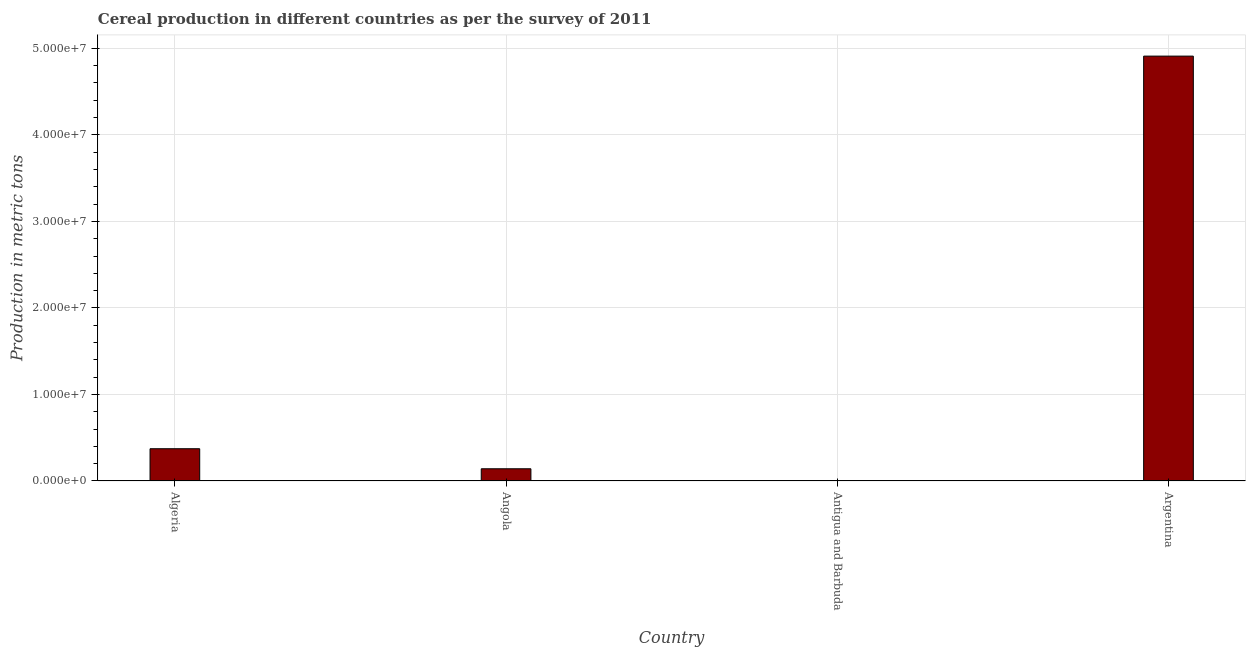Does the graph contain grids?
Offer a very short reply. Yes. What is the title of the graph?
Make the answer very short. Cereal production in different countries as per the survey of 2011. What is the label or title of the X-axis?
Provide a short and direct response. Country. What is the label or title of the Y-axis?
Make the answer very short. Production in metric tons. What is the cereal production in Algeria?
Provide a succinct answer. 3.73e+06. Across all countries, what is the maximum cereal production?
Your answer should be compact. 4.91e+07. Across all countries, what is the minimum cereal production?
Your answer should be compact. 90. In which country was the cereal production minimum?
Make the answer very short. Antigua and Barbuda. What is the sum of the cereal production?
Offer a terse response. 5.42e+07. What is the difference between the cereal production in Algeria and Antigua and Barbuda?
Offer a terse response. 3.73e+06. What is the average cereal production per country?
Make the answer very short. 1.36e+07. What is the median cereal production?
Ensure brevity in your answer.  2.57e+06. In how many countries, is the cereal production greater than 18000000 metric tons?
Your response must be concise. 1. Is the cereal production in Algeria less than that in Argentina?
Give a very brief answer. Yes. Is the difference between the cereal production in Angola and Argentina greater than the difference between any two countries?
Give a very brief answer. No. What is the difference between the highest and the second highest cereal production?
Keep it short and to the point. 4.54e+07. Is the sum of the cereal production in Antigua and Barbuda and Argentina greater than the maximum cereal production across all countries?
Offer a terse response. Yes. What is the difference between the highest and the lowest cereal production?
Your answer should be very brief. 4.91e+07. In how many countries, is the cereal production greater than the average cereal production taken over all countries?
Give a very brief answer. 1. How many bars are there?
Offer a very short reply. 4. How many countries are there in the graph?
Give a very brief answer. 4. Are the values on the major ticks of Y-axis written in scientific E-notation?
Your answer should be compact. Yes. What is the Production in metric tons in Algeria?
Offer a very short reply. 3.73e+06. What is the Production in metric tons of Angola?
Give a very brief answer. 1.41e+06. What is the Production in metric tons in Argentina?
Provide a short and direct response. 4.91e+07. What is the difference between the Production in metric tons in Algeria and Angola?
Provide a succinct answer. 2.32e+06. What is the difference between the Production in metric tons in Algeria and Antigua and Barbuda?
Keep it short and to the point. 3.73e+06. What is the difference between the Production in metric tons in Algeria and Argentina?
Offer a terse response. -4.54e+07. What is the difference between the Production in metric tons in Angola and Antigua and Barbuda?
Give a very brief answer. 1.41e+06. What is the difference between the Production in metric tons in Angola and Argentina?
Offer a terse response. -4.77e+07. What is the difference between the Production in metric tons in Antigua and Barbuda and Argentina?
Your answer should be compact. -4.91e+07. What is the ratio of the Production in metric tons in Algeria to that in Angola?
Make the answer very short. 2.64. What is the ratio of the Production in metric tons in Algeria to that in Antigua and Barbuda?
Give a very brief answer. 4.14e+04. What is the ratio of the Production in metric tons in Algeria to that in Argentina?
Your response must be concise. 0.08. What is the ratio of the Production in metric tons in Angola to that in Antigua and Barbuda?
Provide a succinct answer. 1.57e+04. What is the ratio of the Production in metric tons in Angola to that in Argentina?
Provide a succinct answer. 0.03. 